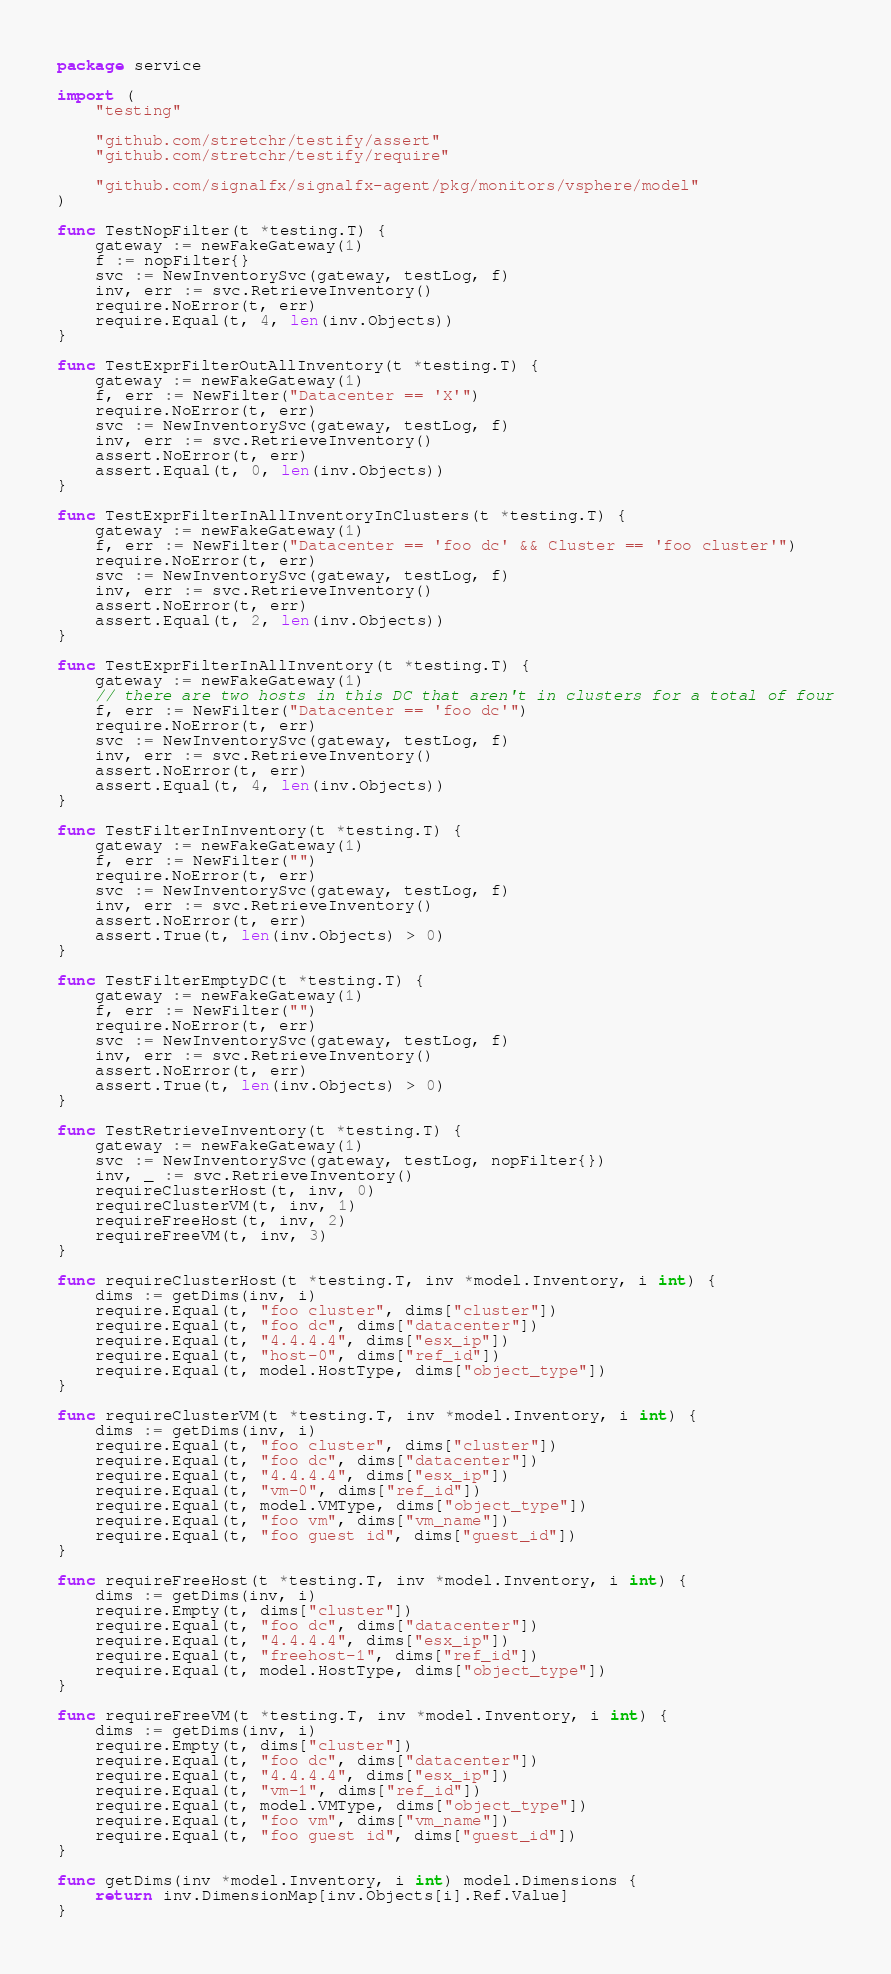<code> <loc_0><loc_0><loc_500><loc_500><_Go_>package service

import (
	"testing"

	"github.com/stretchr/testify/assert"
	"github.com/stretchr/testify/require"

	"github.com/signalfx/signalfx-agent/pkg/monitors/vsphere/model"
)

func TestNopFilter(t *testing.T) {
	gateway := newFakeGateway(1)
	f := nopFilter{}
	svc := NewInventorySvc(gateway, testLog, f)
	inv, err := svc.RetrieveInventory()
	require.NoError(t, err)
	require.Equal(t, 4, len(inv.Objects))
}

func TestExprFilterOutAllInventory(t *testing.T) {
	gateway := newFakeGateway(1)
	f, err := NewFilter("Datacenter == 'X'")
	require.NoError(t, err)
	svc := NewInventorySvc(gateway, testLog, f)
	inv, err := svc.RetrieveInventory()
	assert.NoError(t, err)
	assert.Equal(t, 0, len(inv.Objects))
}

func TestExprFilterInAllInventoryInClusters(t *testing.T) {
	gateway := newFakeGateway(1)
	f, err := NewFilter("Datacenter == 'foo dc' && Cluster == 'foo cluster'")
	require.NoError(t, err)
	svc := NewInventorySvc(gateway, testLog, f)
	inv, err := svc.RetrieveInventory()
	assert.NoError(t, err)
	assert.Equal(t, 2, len(inv.Objects))
}

func TestExprFilterInAllInventory(t *testing.T) {
	gateway := newFakeGateway(1)
	// there are two hosts in this DC that aren't in clusters for a total of four
	f, err := NewFilter("Datacenter == 'foo dc'")
	require.NoError(t, err)
	svc := NewInventorySvc(gateway, testLog, f)
	inv, err := svc.RetrieveInventory()
	assert.NoError(t, err)
	assert.Equal(t, 4, len(inv.Objects))
}

func TestFilterInInventory(t *testing.T) {
	gateway := newFakeGateway(1)
	f, err := NewFilter("")
	require.NoError(t, err)
	svc := NewInventorySvc(gateway, testLog, f)
	inv, err := svc.RetrieveInventory()
	assert.NoError(t, err)
	assert.True(t, len(inv.Objects) > 0)
}

func TestFilterEmptyDC(t *testing.T) {
	gateway := newFakeGateway(1)
	f, err := NewFilter("")
	require.NoError(t, err)
	svc := NewInventorySvc(gateway, testLog, f)
	inv, err := svc.RetrieveInventory()
	assert.NoError(t, err)
	assert.True(t, len(inv.Objects) > 0)
}

func TestRetrieveInventory(t *testing.T) {
	gateway := newFakeGateway(1)
	svc := NewInventorySvc(gateway, testLog, nopFilter{})
	inv, _ := svc.RetrieveInventory()
	requireClusterHost(t, inv, 0)
	requireClusterVM(t, inv, 1)
	requireFreeHost(t, inv, 2)
	requireFreeVM(t, inv, 3)
}

func requireClusterHost(t *testing.T, inv *model.Inventory, i int) {
	dims := getDims(inv, i)
	require.Equal(t, "foo cluster", dims["cluster"])
	require.Equal(t, "foo dc", dims["datacenter"])
	require.Equal(t, "4.4.4.4", dims["esx_ip"])
	require.Equal(t, "host-0", dims["ref_id"])
	require.Equal(t, model.HostType, dims["object_type"])
}

func requireClusterVM(t *testing.T, inv *model.Inventory, i int) {
	dims := getDims(inv, i)
	require.Equal(t, "foo cluster", dims["cluster"])
	require.Equal(t, "foo dc", dims["datacenter"])
	require.Equal(t, "4.4.4.4", dims["esx_ip"])
	require.Equal(t, "vm-0", dims["ref_id"])
	require.Equal(t, model.VMType, dims["object_type"])
	require.Equal(t, "foo vm", dims["vm_name"])
	require.Equal(t, "foo guest id", dims["guest_id"])
}

func requireFreeHost(t *testing.T, inv *model.Inventory, i int) {
	dims := getDims(inv, i)
	require.Empty(t, dims["cluster"])
	require.Equal(t, "foo dc", dims["datacenter"])
	require.Equal(t, "4.4.4.4", dims["esx_ip"])
	require.Equal(t, "freehost-1", dims["ref_id"])
	require.Equal(t, model.HostType, dims["object_type"])
}

func requireFreeVM(t *testing.T, inv *model.Inventory, i int) {
	dims := getDims(inv, i)
	require.Empty(t, dims["cluster"])
	require.Equal(t, "foo dc", dims["datacenter"])
	require.Equal(t, "4.4.4.4", dims["esx_ip"])
	require.Equal(t, "vm-1", dims["ref_id"])
	require.Equal(t, model.VMType, dims["object_type"])
	require.Equal(t, "foo vm", dims["vm_name"])
	require.Equal(t, "foo guest id", dims["guest_id"])
}

func getDims(inv *model.Inventory, i int) model.Dimensions {
	return inv.DimensionMap[inv.Objects[i].Ref.Value]
}
</code> 